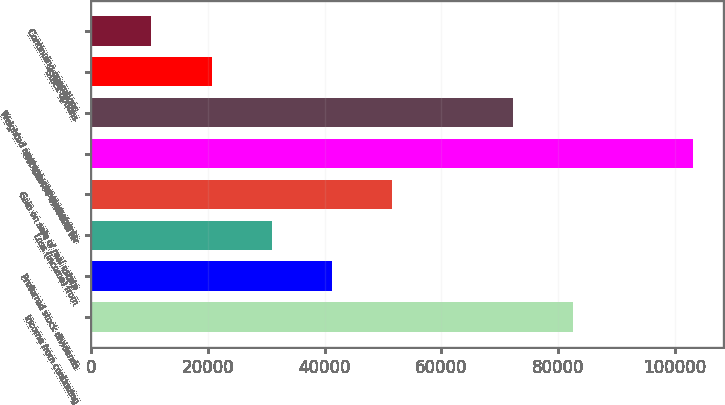Convert chart. <chart><loc_0><loc_0><loc_500><loc_500><bar_chart><fcel>Income from continuing<fcel>Preferred stock dividends<fcel>Loss (income) from<fcel>Gain on sale of real estate<fcel>Net income available for<fcel>Weighted average common shares<fcel>Stock options<fcel>Continuing operations<nl><fcel>82509.6<fcel>41254.8<fcel>30941.1<fcel>51568.5<fcel>103137<fcel>72195.9<fcel>20627.4<fcel>10313.7<nl></chart> 